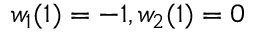<formula> <loc_0><loc_0><loc_500><loc_500>w _ { 1 } ( 1 ) = - 1 , w _ { 2 } ( 1 ) = 0</formula> 